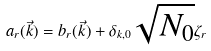<formula> <loc_0><loc_0><loc_500><loc_500>a _ { r } ( \vec { k } ) = b _ { r } ( \vec { k } ) + \delta _ { k , 0 } \sqrt { N _ { 0 } } \zeta _ { r }</formula> 